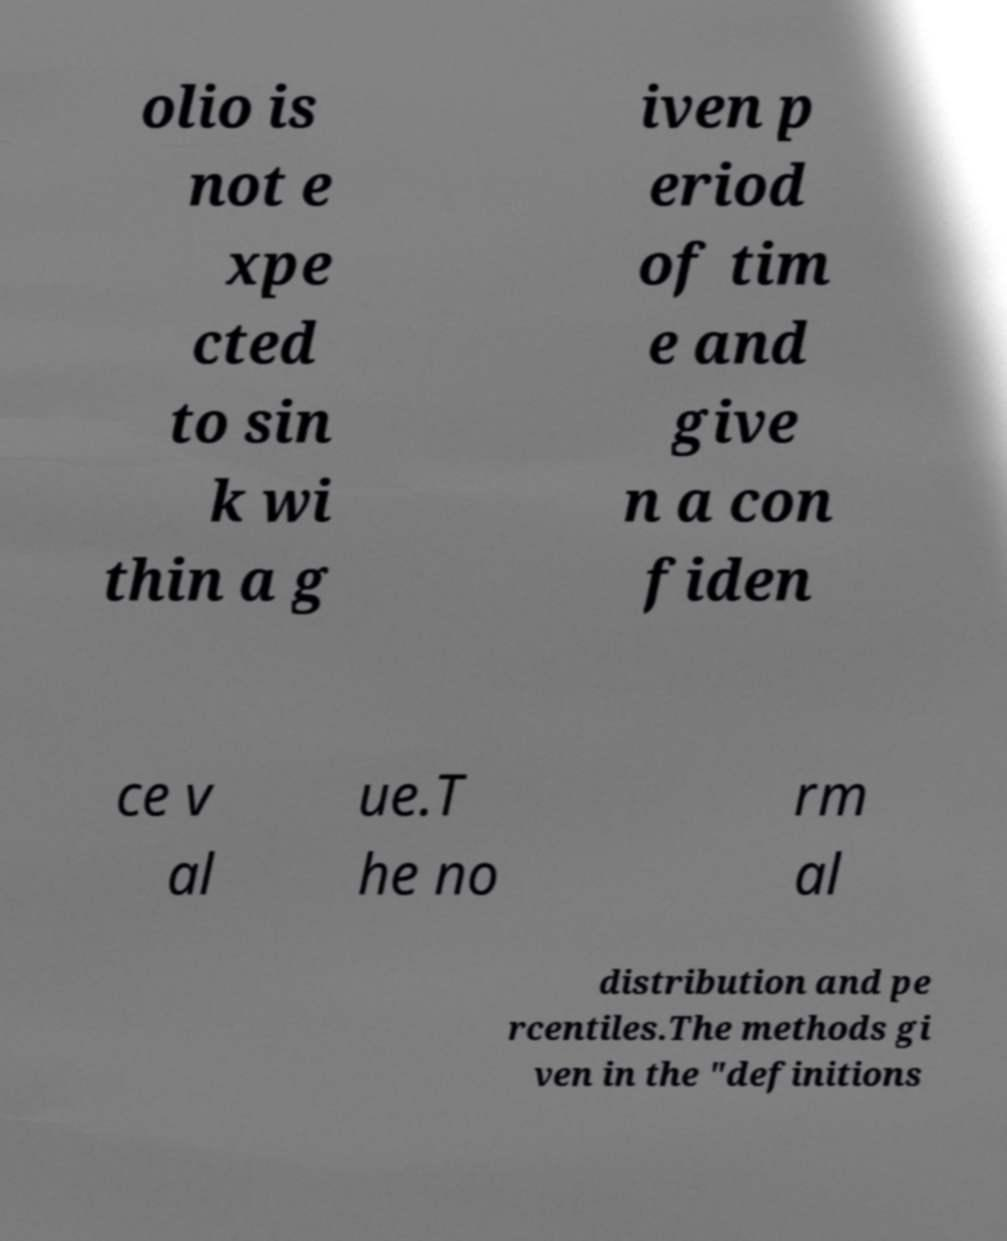There's text embedded in this image that I need extracted. Can you transcribe it verbatim? olio is not e xpe cted to sin k wi thin a g iven p eriod of tim e and give n a con fiden ce v al ue.T he no rm al distribution and pe rcentiles.The methods gi ven in the "definitions 